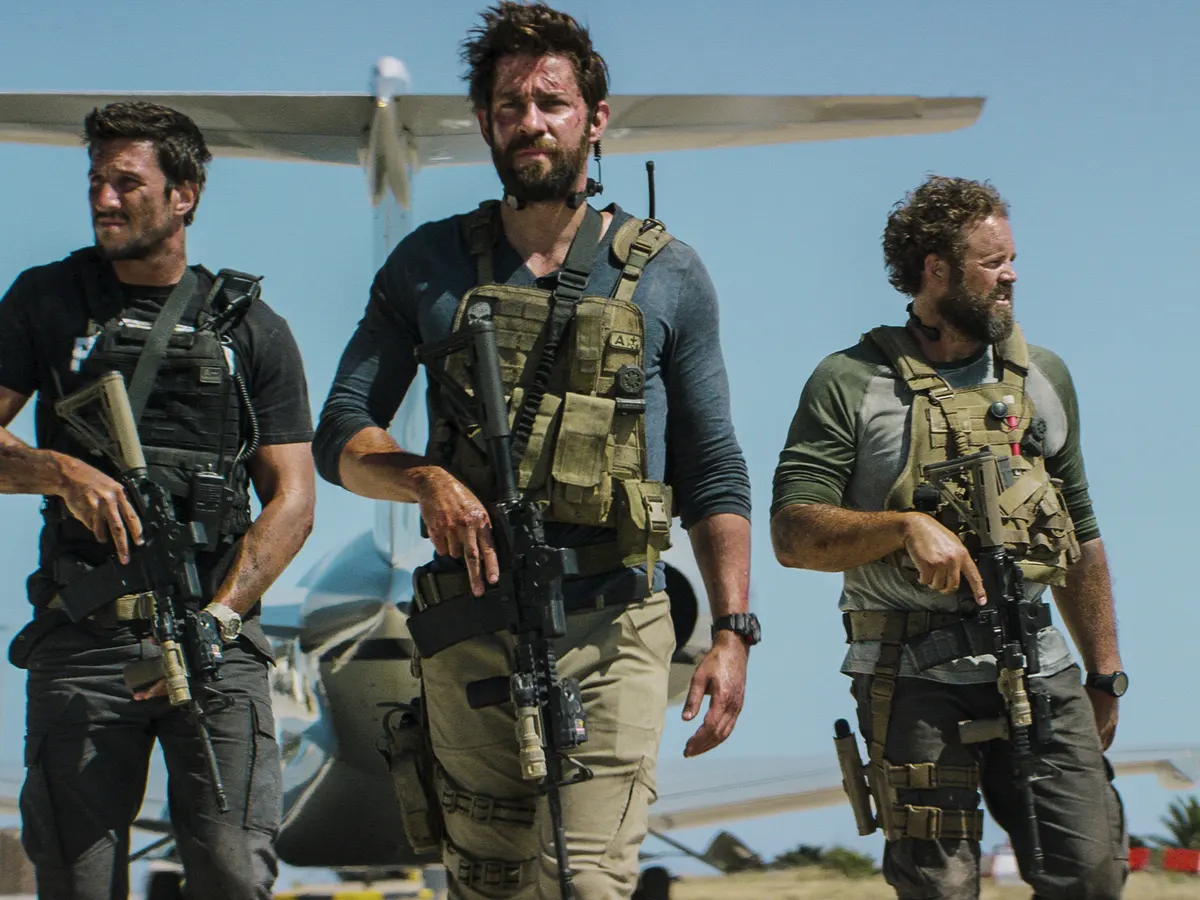How would you describe the mood and atmosphere captured in this image? The mood and atmosphere of this image are intense and focused, imbued with a sense of urgency and readiness for action. The serious expressions on the men's faces, coupled with their tactical gear and armed stance, create an environment of high stakes and potential danger. The bright sunlight and clear blue sky contrast with the gravity of their mission, highlighting the harshness of the setting. The sandy ground and small aircraft in the background add context, suggesting a remote, possibly hostile location. Overall, the image captures a moment poised on the brink of conflict, with an underlying current of camaraderie and resolve. What could be the potential aftermath of the scene shown in the image? The aftermath might see the team successfully completing their mission, extracting crucial intelligence or rescuing important personnel, and making their way to the aircraft for a quick getaway. This could lead to a hurried exit under pressure, potentially pursued by adversaries. Alternatively, they could face unforeseen complications, such as additional enemy forces or environmental challenges, forcing them to adapt their strategy on the fly. The aftermath could also explore the personal toll on the team members, the physical and emotional impacts of their high-stakes operation, and set the stage for future missions influenced by their experiences in this moment. 